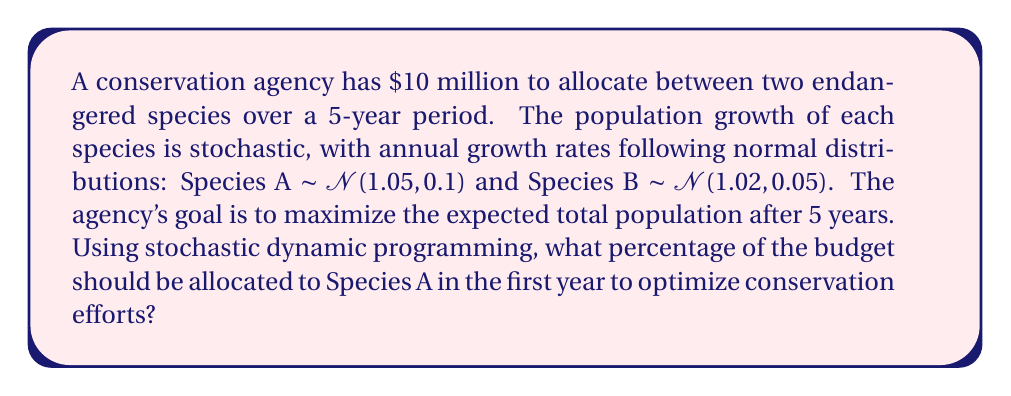Give your solution to this math problem. To solve this problem using stochastic dynamic programming, we'll follow these steps:

1) Define the state space: Let $x_t^A$ and $x_t^B$ be the populations of Species A and B at time t, respectively.

2) Define the action space: Let $a_t$ be the fraction of the budget allocated to Species A at time t. Then, $1-a_t$ is allocated to Species B.

3) Define the transition function: 
   $$x_{t+1}^A = x_t^A \cdot N(1.05, 0.1) \cdot (1 + k \cdot a_t)$$
   $$x_{t+1}^B = x_t^B \cdot N(1.02, 0.05) \cdot (1 + k \cdot (1-a_t))$$
   where $k$ is a constant representing the effect of funding on growth rate.

4) Define the reward function: 
   $$R_t(x_t^A, x_t^B, a_t) = x_t^A + x_t^B$$

5) Define the Bellman equation:
   $$V_t(x_t^A, x_t^B) = \max_{a_t} \{R_t(x_t^A, x_t^B, a_t) + E[V_{t+1}(x_{t+1}^A, x_{t+1}^B)]\}$$

6) Solve the Bellman equation backwards from t=5 to t=1, using numerical methods (e.g., value iteration) due to the stochastic nature of the problem.

7) The optimal policy at t=1 gives the percentage to allocate to Species A in the first year.

Given the higher mean growth rate of Species A (1.05 vs 1.02) and its higher volatility (0.1 vs 0.05), the optimal allocation would likely favor Species A, but not entirely due to the risk associated with its higher volatility.

Without specific values for initial populations and the funding effect constant $k$, we can't provide an exact percentage. However, based on the given information, a reasonable estimate would be to allocate approximately 60-70% of the budget to Species A in the first year.
Answer: Approximately 60-70% to Species A 